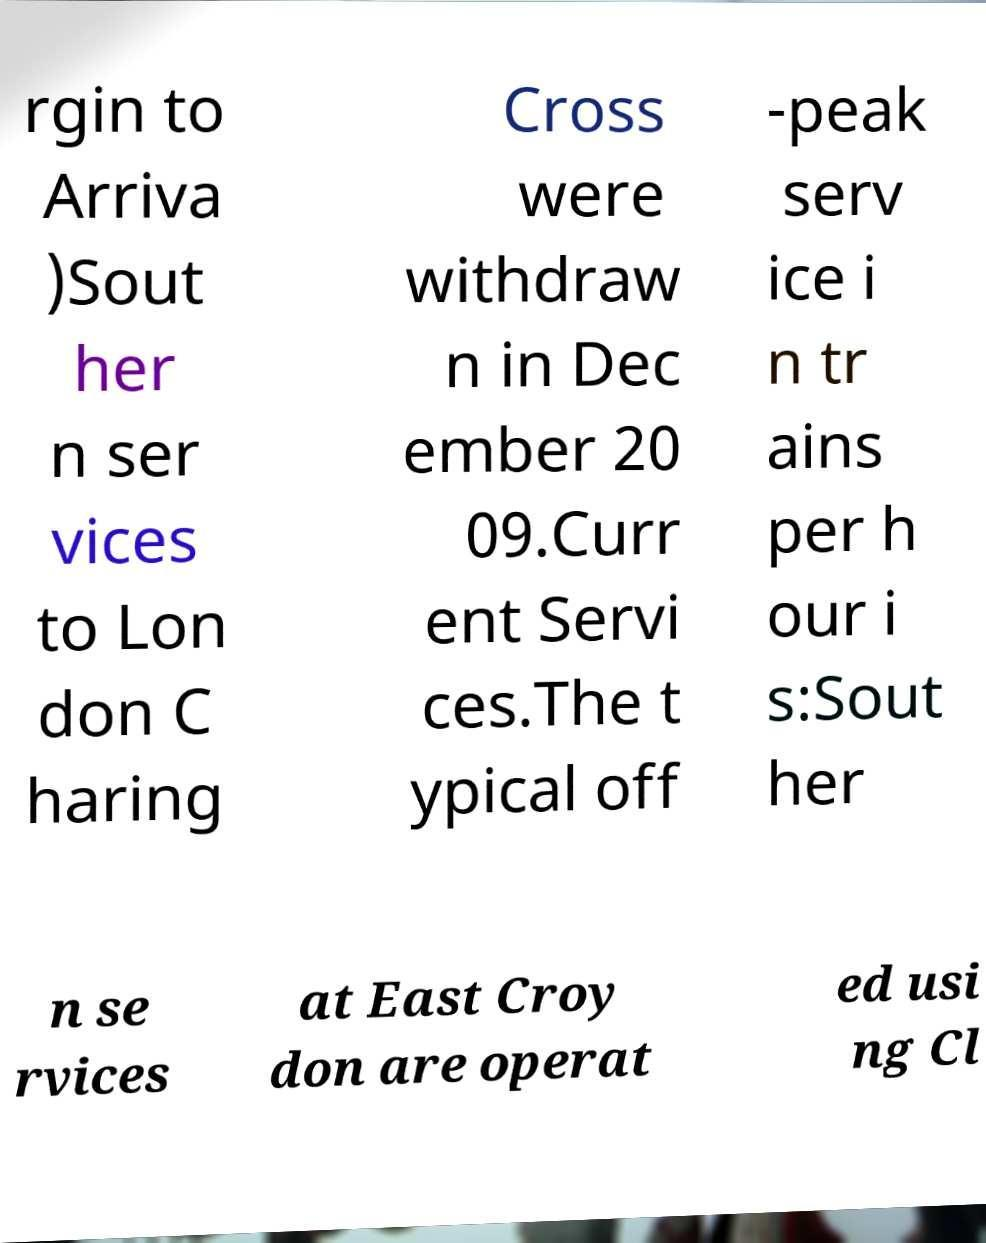Can you accurately transcribe the text from the provided image for me? rgin to Arriva )Sout her n ser vices to Lon don C haring Cross were withdraw n in Dec ember 20 09.Curr ent Servi ces.The t ypical off -peak serv ice i n tr ains per h our i s:Sout her n se rvices at East Croy don are operat ed usi ng Cl 